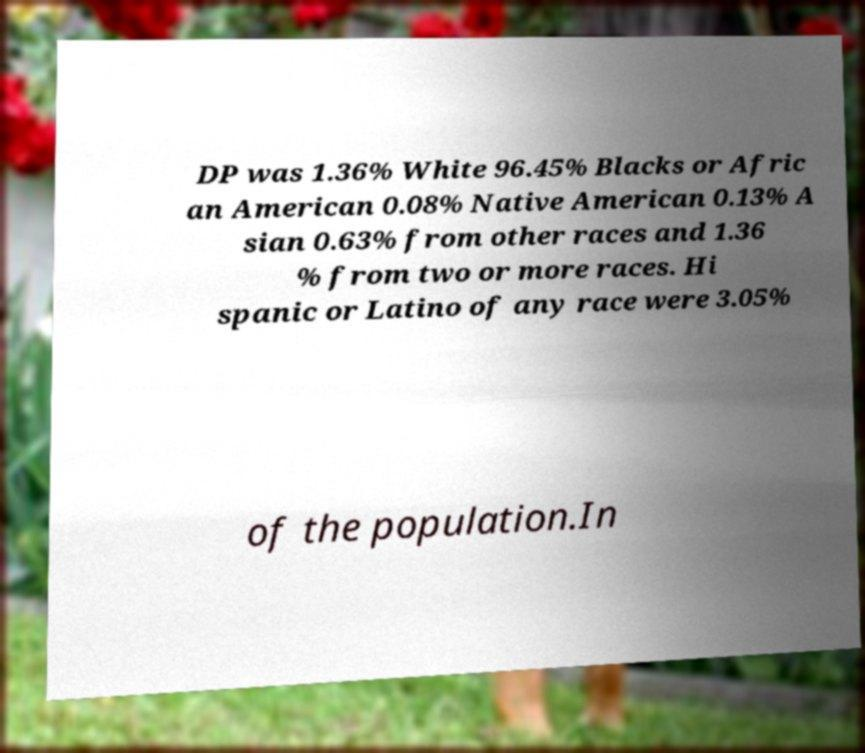What messages or text are displayed in this image? I need them in a readable, typed format. DP was 1.36% White 96.45% Blacks or Afric an American 0.08% Native American 0.13% A sian 0.63% from other races and 1.36 % from two or more races. Hi spanic or Latino of any race were 3.05% of the population.In 